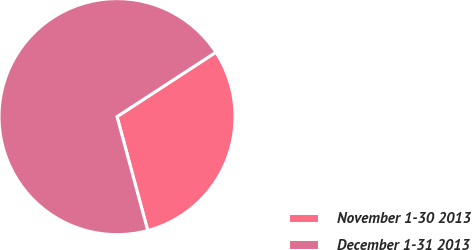Convert chart to OTSL. <chart><loc_0><loc_0><loc_500><loc_500><pie_chart><fcel>November 1-30 2013<fcel>December 1-31 2013<nl><fcel>30.0%<fcel>70.0%<nl></chart> 